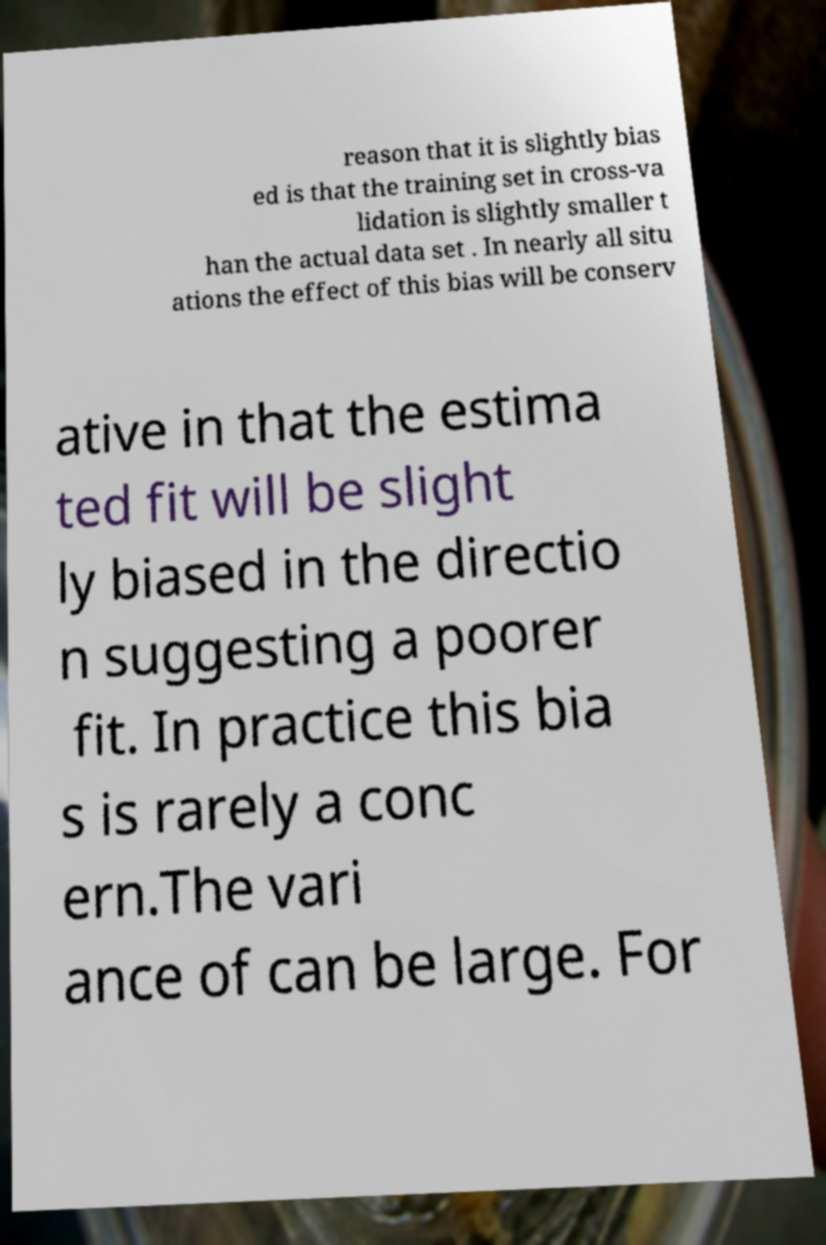Please read and relay the text visible in this image. What does it say? reason that it is slightly bias ed is that the training set in cross-va lidation is slightly smaller t han the actual data set . In nearly all situ ations the effect of this bias will be conserv ative in that the estima ted fit will be slight ly biased in the directio n suggesting a poorer fit. In practice this bia s is rarely a conc ern.The vari ance of can be large. For 